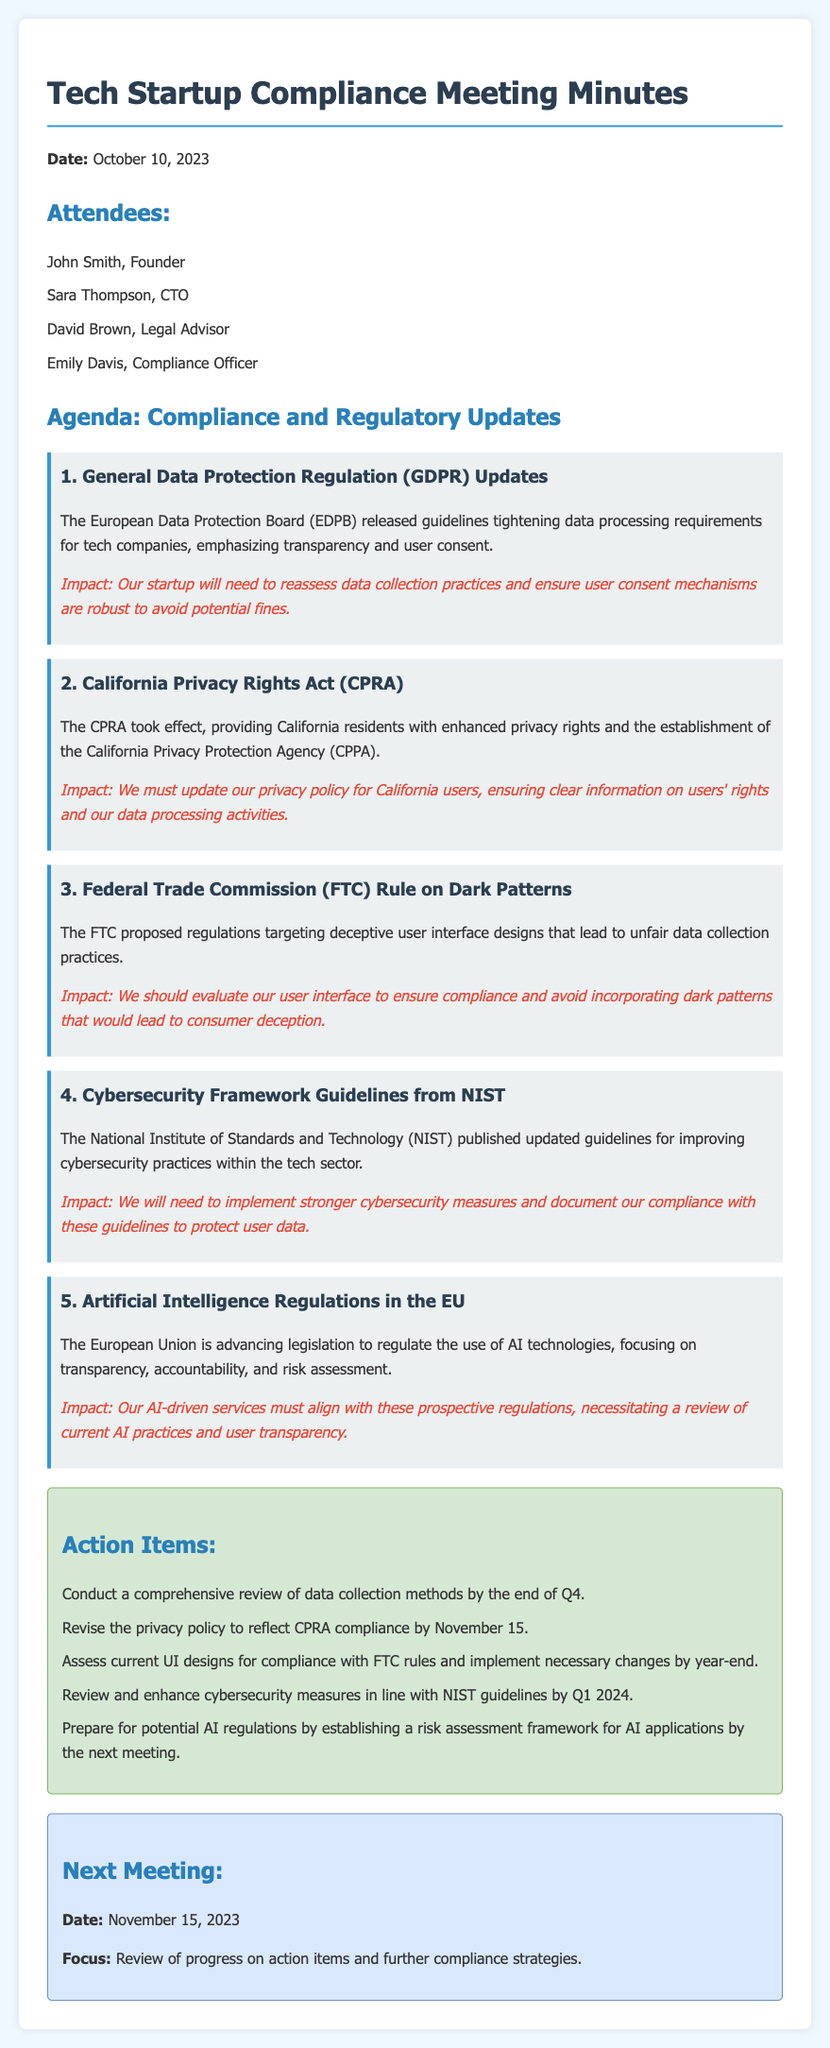what date was the meeting held? The meeting date is explicitly stated in the document's header section.
Answer: October 10, 2023 who is the Legal Advisor present at the meeting? The attendees section lists the individuals present, providing roles associated with their names.
Answer: David Brown what is the first item discussed in the regulatory updates? The summarized items provide a clear order of topics addressed during the meeting.
Answer: General Data Protection Regulation (GDPR) Updates what is the impact of the CPRA on the company? The impact section under the corresponding item explains how the regulation affects company operations.
Answer: Update privacy policy for California users when is the next meeting scheduled? The next meeting date is mentioned towards the end of the document.
Answer: November 15, 2023 what action item involves enhancing cybersecurity measures? The action items provide specific tasks to be completed, including their alignment with guidelines.
Answer: Review and enhance cybersecurity measures in line with NIST guidelines by Q1 2024 how many action items are listed in the document? The total number of action items can be counted from the action items section.
Answer: Five what agency was established under the CPRA? The CPRA section includes information about the establishment of specific regulatory bodies.
Answer: California Privacy Protection Agency (CPPA) 